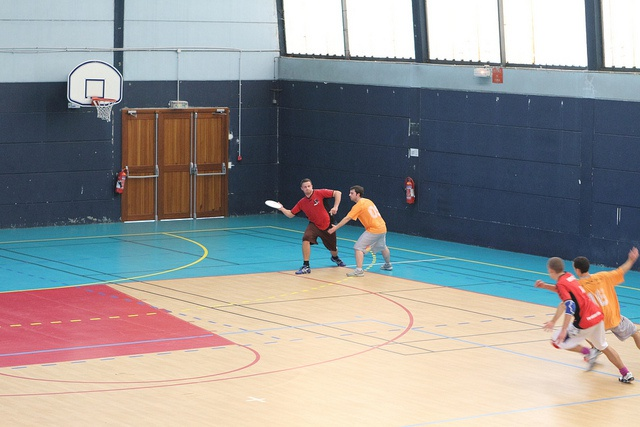Describe the objects in this image and their specific colors. I can see people in lightblue, tan, salmon, lightgray, and darkgray tones, people in lightblue, orange, darkgray, salmon, and tan tones, people in lightblue, brown, black, maroon, and gray tones, people in lightblue, darkgray, orange, and tan tones, and frisbee in lightblue, white, black, gray, and darkgray tones in this image. 